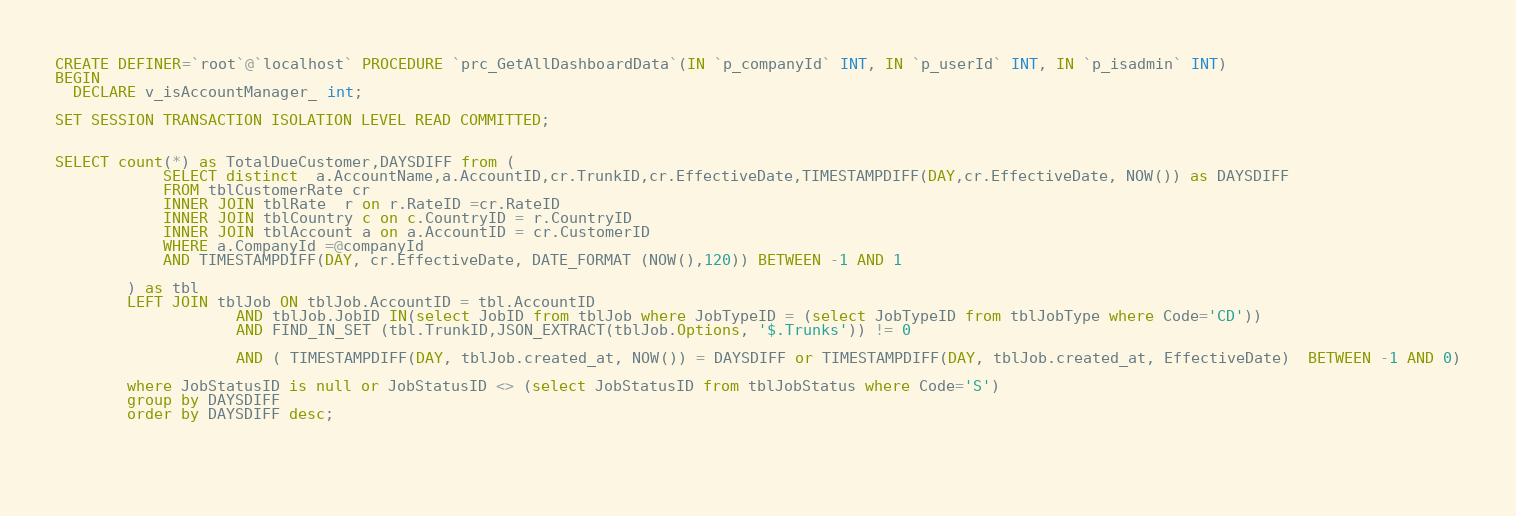<code> <loc_0><loc_0><loc_500><loc_500><_SQL_>CREATE DEFINER=`root`@`localhost` PROCEDURE `prc_GetAllDashboardData`(IN `p_companyId` INT, IN `p_userId` INT, IN `p_isadmin` INT)
BEGIN
  DECLARE v_isAccountManager_ int;
   
SET SESSION TRANSACTION ISOLATION LEVEL READ COMMITTED;
 

SELECT count(*) as TotalDueCustomer,DAYSDIFF from (
			SELECT distinct  a.AccountName,a.AccountID,cr.TrunkID,cr.EffectiveDate,TIMESTAMPDIFF(DAY,cr.EffectiveDate, NOW()) as DAYSDIFF
			FROM tblCustomerRate cr
			INNER JOIN tblRate  r on r.RateID =cr.RateID
			INNER JOIN tblCountry c on c.CountryID = r.CountryID
			INNER JOIN tblAccount a on a.AccountID = cr.CustomerID
			WHERE a.CompanyId =@companyId
			AND TIMESTAMPDIFF(DAY, cr.EffectiveDate, DATE_FORMAT (NOW(),120)) BETWEEN -1 AND 1

		) as tbl
		LEFT JOIN tblJob ON tblJob.AccountID = tbl.AccountID
					AND tblJob.JobID IN(select JobID from tblJob where JobTypeID = (select JobTypeID from tblJobType where Code='CD'))
					AND FIND_IN_SET (tbl.TrunkID,JSON_EXTRACT(tblJob.Options, '$.Trunks')) != 0

					AND ( TIMESTAMPDIFF(DAY, tblJob.created_at, NOW()) = DAYSDIFF or TIMESTAMPDIFF(DAY, tblJob.created_at, EffectiveDate)  BETWEEN -1 AND 0)

		where JobStatusID is null or JobStatusID <> (select JobStatusID from tblJobStatus where Code='S')
		group by DAYSDIFF
		order by DAYSDIFF desc;

 
        
</code> 